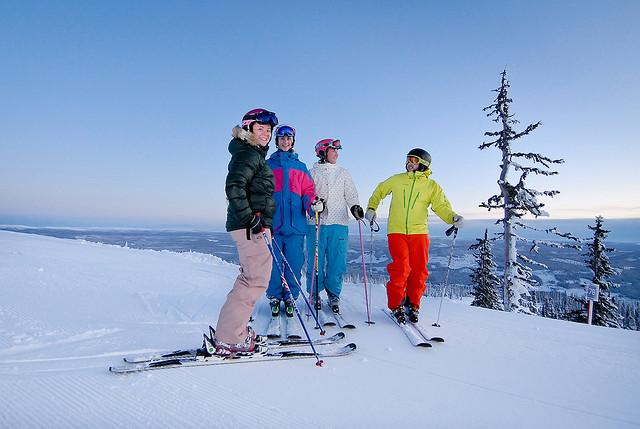Why are they stopped? Please explain your reasoning. at summit. People on skis are standing together at the top of a mountain. 